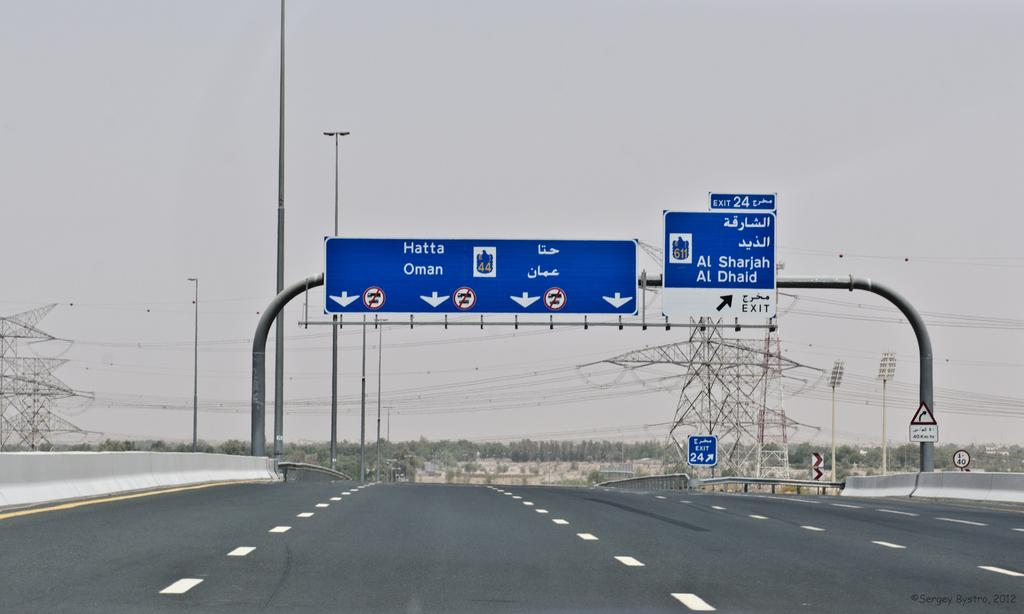<image>
Relay a brief, clear account of the picture shown. Two signs in the highway showing the way to Hatta and Al Sharjah 